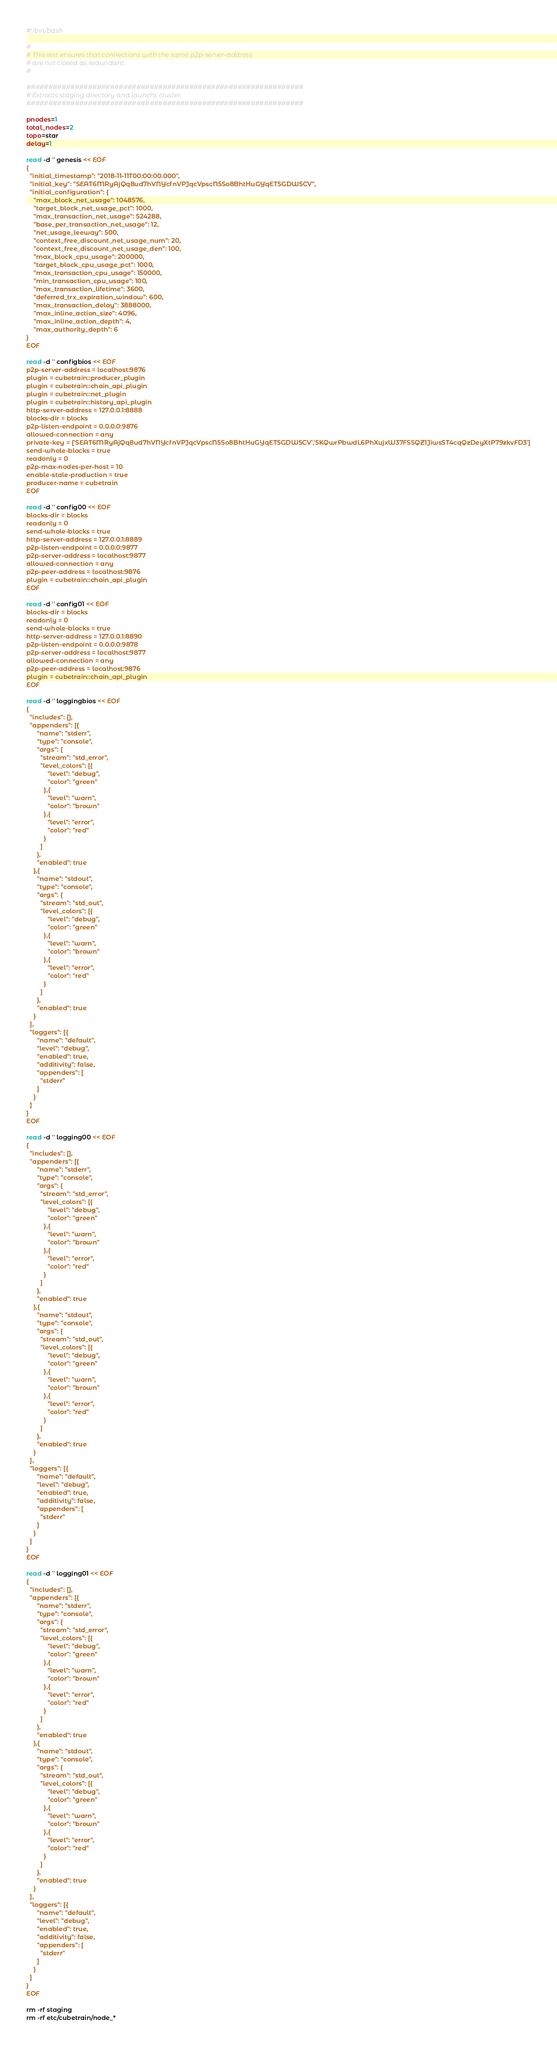<code> <loc_0><loc_0><loc_500><loc_500><_Bash_>#!/bin/bash

#
# This test ensures that connections with the same p2p-server-address
# are not closed as redundant.
#

###############################################################
# Extracts staging directory and launchs cluster.
###############################################################

pnodes=1
total_nodes=2
topo=star
delay=1

read -d '' genesis << EOF
{
  "initial_timestamp": "2018-11-11T00:00:00.000",
  "initial_key": "SEAT6MRyAjQq8ud7hVNYcfnVPJqcVpscN5So8BhtHuGYqET5GDW5CV",
  "initial_configuration": {
    "max_block_net_usage": 1048576,
    "target_block_net_usage_pct": 1000,
    "max_transaction_net_usage": 524288,
    "base_per_transaction_net_usage": 12,
    "net_usage_leeway": 500,
    "context_free_discount_net_usage_num": 20,
    "context_free_discount_net_usage_den": 100,
    "max_block_cpu_usage": 200000,
    "target_block_cpu_usage_pct": 1000,
    "max_transaction_cpu_usage": 150000,
    "min_transaction_cpu_usage": 100,
    "max_transaction_lifetime": 3600,
    "deferred_trx_expiration_window": 600,
    "max_transaction_delay": 3888000,
    "max_inline_action_size": 4096,
    "max_inline_action_depth": 4,
    "max_authority_depth": 6
}
EOF

read -d '' configbios << EOF
p2p-server-address = localhost:9876
plugin = cubetrain::producer_plugin
plugin = cubetrain::chain_api_plugin
plugin = cubetrain::net_plugin
plugin = cubetrain::history_api_plugin
http-server-address = 127.0.0.1:8888
blocks-dir = blocks
p2p-listen-endpoint = 0.0.0.0:9876
allowed-connection = any
private-key = ['SEAT6MRyAjQq8ud7hVNYcfnVPJqcVpscN5So8BhtHuGYqET5GDW5CV','5KQwrPbwdL6PhXujxW37FSSQZ1JiwsST4cqQzDeyXtP79zkvFD3']
send-whole-blocks = true
readonly = 0
p2p-max-nodes-per-host = 10
enable-stale-production = true
producer-name = cubetrain
EOF

read -d '' config00 << EOF
blocks-dir = blocks
readonly = 0
send-whole-blocks = true
http-server-address = 127.0.0.1:8889
p2p-listen-endpoint = 0.0.0.0:9877
p2p-server-address = localhost:9877
allowed-connection = any
p2p-peer-address = localhost:9876
plugin = cubetrain::chain_api_plugin
EOF

read -d '' config01 << EOF
blocks-dir = blocks
readonly = 0
send-whole-blocks = true
http-server-address = 127.0.0.1:8890
p2p-listen-endpoint = 0.0.0.0:9878
p2p-server-address = localhost:9877
allowed-connection = any
p2p-peer-address = localhost:9876
plugin = cubetrain::chain_api_plugin
EOF

read -d '' loggingbios << EOF
{
  "includes": [],
  "appenders": [{
      "name": "stderr",
      "type": "console",
      "args": {
        "stream": "std_error",
        "level_colors": [{
            "level": "debug",
            "color": "green"
          },{
            "level": "warn",
            "color": "brown"
          },{
            "level": "error",
            "color": "red"
          }
        ]
      },
      "enabled": true
    },{
      "name": "stdout",
      "type": "console",
      "args": {
        "stream": "std_out",
        "level_colors": [{
            "level": "debug",
            "color": "green"
          },{
            "level": "warn",
            "color": "brown"
          },{
            "level": "error",
            "color": "red"
          }
        ]
      },
      "enabled": true
    }
  ],
  "loggers": [{
      "name": "default",
      "level": "debug",
      "enabled": true,
      "additivity": false,
      "appenders": [
        "stderr"
      ]
    }
  ]
}
EOF

read -d '' logging00 << EOF
{
  "includes": [],
  "appenders": [{
      "name": "stderr",
      "type": "console",
      "args": {
        "stream": "std_error",
        "level_colors": [{
            "level": "debug",
            "color": "green"
          },{
            "level": "warn",
            "color": "brown"
          },{
            "level": "error",
            "color": "red"
          }
        ]
      },
      "enabled": true
    },{
      "name": "stdout",
      "type": "console",
      "args": {
        "stream": "std_out",
        "level_colors": [{
            "level": "debug",
            "color": "green"
          },{
            "level": "warn",
            "color": "brown"
          },{
            "level": "error",
            "color": "red"
          }
        ]
      },
      "enabled": true
    }
  ],
  "loggers": [{
      "name": "default",
      "level": "debug",
      "enabled": true,
      "additivity": false,
      "appenders": [
        "stderr"
      ]
    }
  ]
}
EOF

read -d '' logging01 << EOF
{
  "includes": [],
  "appenders": [{
      "name": "stderr",
      "type": "console",
      "args": {
        "stream": "std_error",
        "level_colors": [{
            "level": "debug",
            "color": "green"
          },{
            "level": "warn",
            "color": "brown"
          },{
            "level": "error",
            "color": "red"
          }
        ]
      },
      "enabled": true
    },{
      "name": "stdout",
      "type": "console",
      "args": {
        "stream": "std_out",
        "level_colors": [{
            "level": "debug",
            "color": "green"
          },{
            "level": "warn",
            "color": "brown"
          },{
            "level": "error",
            "color": "red"
          }
        ]
      },
      "enabled": true
    }
  ],
  "loggers": [{
      "name": "default",
      "level": "debug",
      "enabled": true,
      "additivity": false,
      "appenders": [
        "stderr"
      ]
    }
  ]
}
EOF

rm -rf staging
rm -rf etc/cubetrain/node_*</code> 